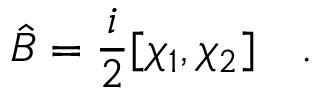Convert formula to latex. <formula><loc_0><loc_0><loc_500><loc_500>\hat { B } = { \frac { i } { 2 } } [ \chi _ { 1 } , \chi _ { 2 } ] \quad .</formula> 